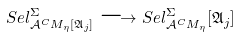Convert formula to latex. <formula><loc_0><loc_0><loc_500><loc_500>S e l ^ { \Sigma } _ { \mathcal { A } ^ { C } M _ { \eta } [ \mathfrak { A } _ { j } ] } \longrightarrow S e l ^ { \Sigma } _ { \mathcal { A } ^ { C } M _ { \eta } } [ \mathfrak { A } _ { j } ]</formula> 